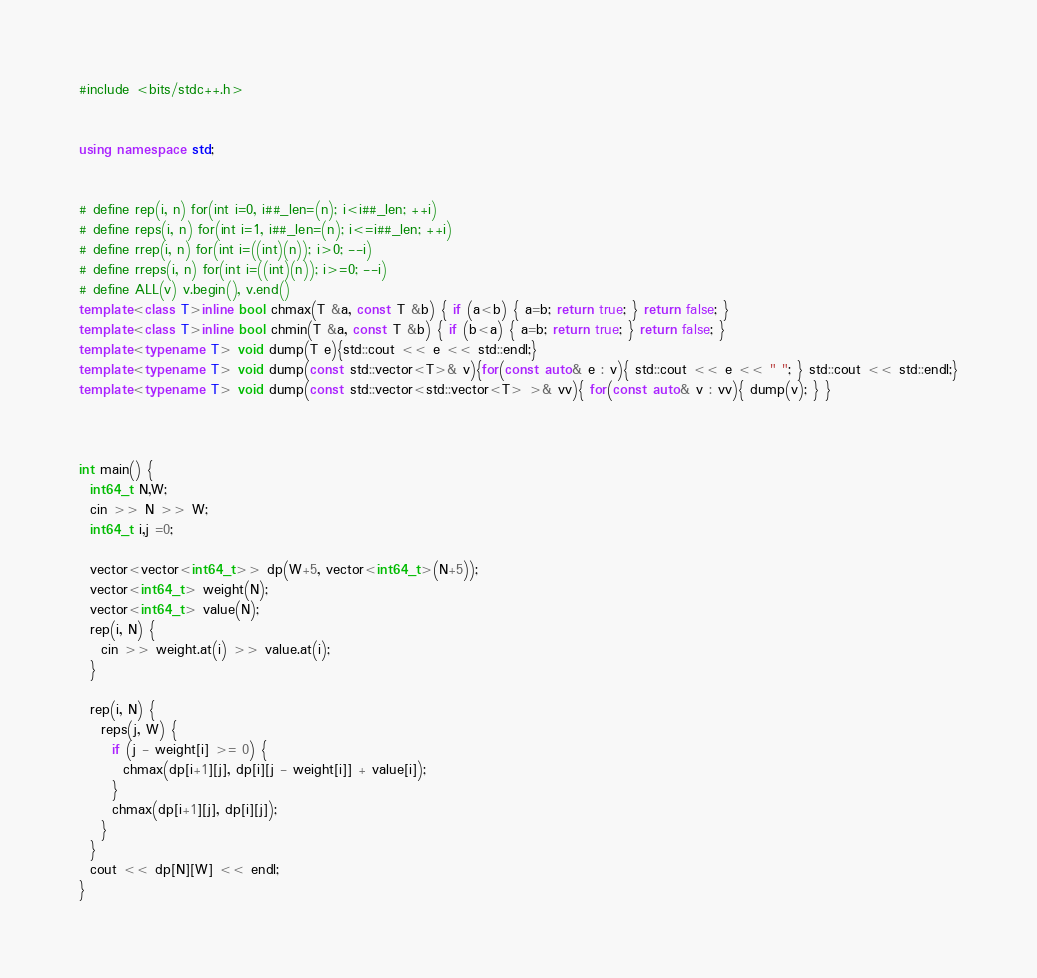Convert code to text. <code><loc_0><loc_0><loc_500><loc_500><_C++_>#include <bits/stdc++.h>


using namespace std;


# define rep(i, n) for(int i=0, i##_len=(n); i<i##_len; ++i)
# define reps(i, n) for(int i=1, i##_len=(n); i<=i##_len; ++i)
# define rrep(i, n) for(int i=((int)(n)); i>0; --i)
# define rreps(i, n) for(int i=((int)(n)); i>=0; --i)
# define ALL(v) v.begin(), v.end()
template<class T>inline bool chmax(T &a, const T &b) { if (a<b) { a=b; return true; } return false; }
template<class T>inline bool chmin(T &a, const T &b) { if (b<a) { a=b; return true; } return false; }
template<typename T> void dump(T e){std::cout << e << std::endl;}
template<typename T> void dump(const std::vector<T>& v){for(const auto& e : v){ std::cout << e << " "; } std::cout << std::endl;}
template<typename T> void dump(const std::vector<std::vector<T> >& vv){ for(const auto& v : vv){ dump(v); } }



int main() {
  int64_t N,W;
  cin >> N >> W;
  int64_t i,j =0;
  
  vector<vector<int64_t>> dp(W+5, vector<int64_t>(N+5));
  vector<int64_t> weight(N);
  vector<int64_t> value(N);
  rep(i, N) {
    cin >> weight.at(i) >> value.at(i);
  }
  
  rep(i, N) {
    reps(j, W) {
      if (j - weight[i] >= 0) {
        chmax(dp[i+1][j], dp[i][j - weight[i]] + value[i]);
      }
      chmax(dp[i+1][j], dp[i][j]);
    }
  }
  cout << dp[N][W] << endl;
}
</code> 